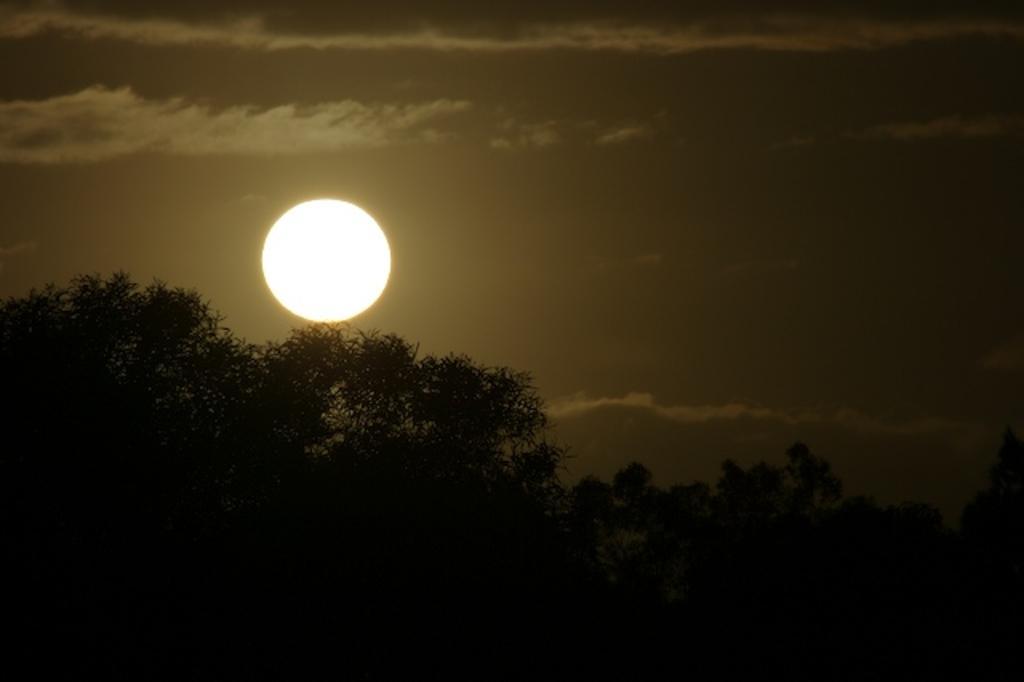Can you describe this image briefly? This image consists of sun in the sky along with the clouds. At the bottom, there are trees. 